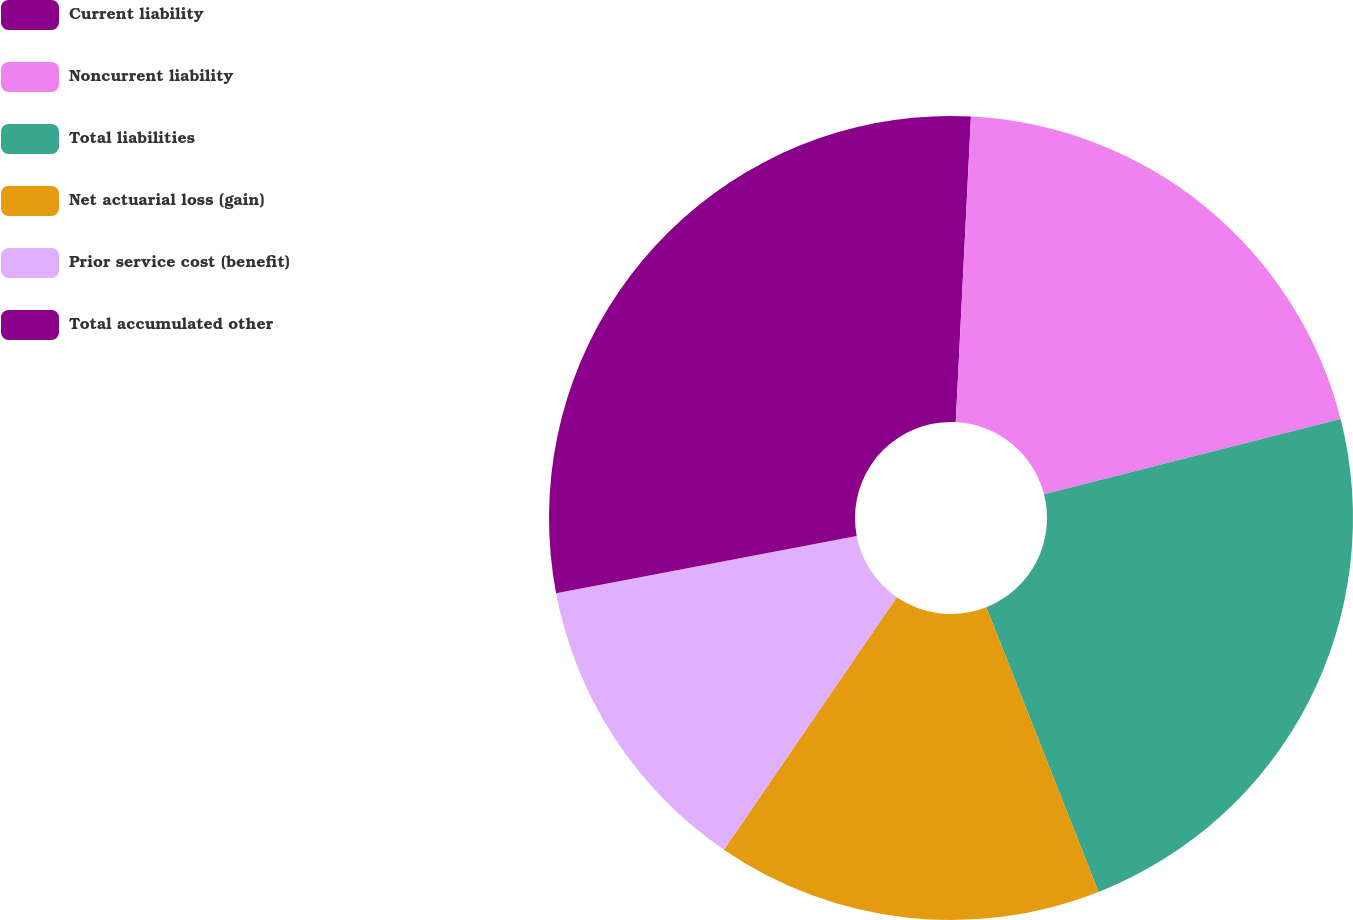Convert chart to OTSL. <chart><loc_0><loc_0><loc_500><loc_500><pie_chart><fcel>Current liability<fcel>Noncurrent liability<fcel>Total liabilities<fcel>Net actuarial loss (gain)<fcel>Prior service cost (benefit)<fcel>Total accumulated other<nl><fcel>0.79%<fcel>20.25%<fcel>22.97%<fcel>15.54%<fcel>12.45%<fcel>27.99%<nl></chart> 